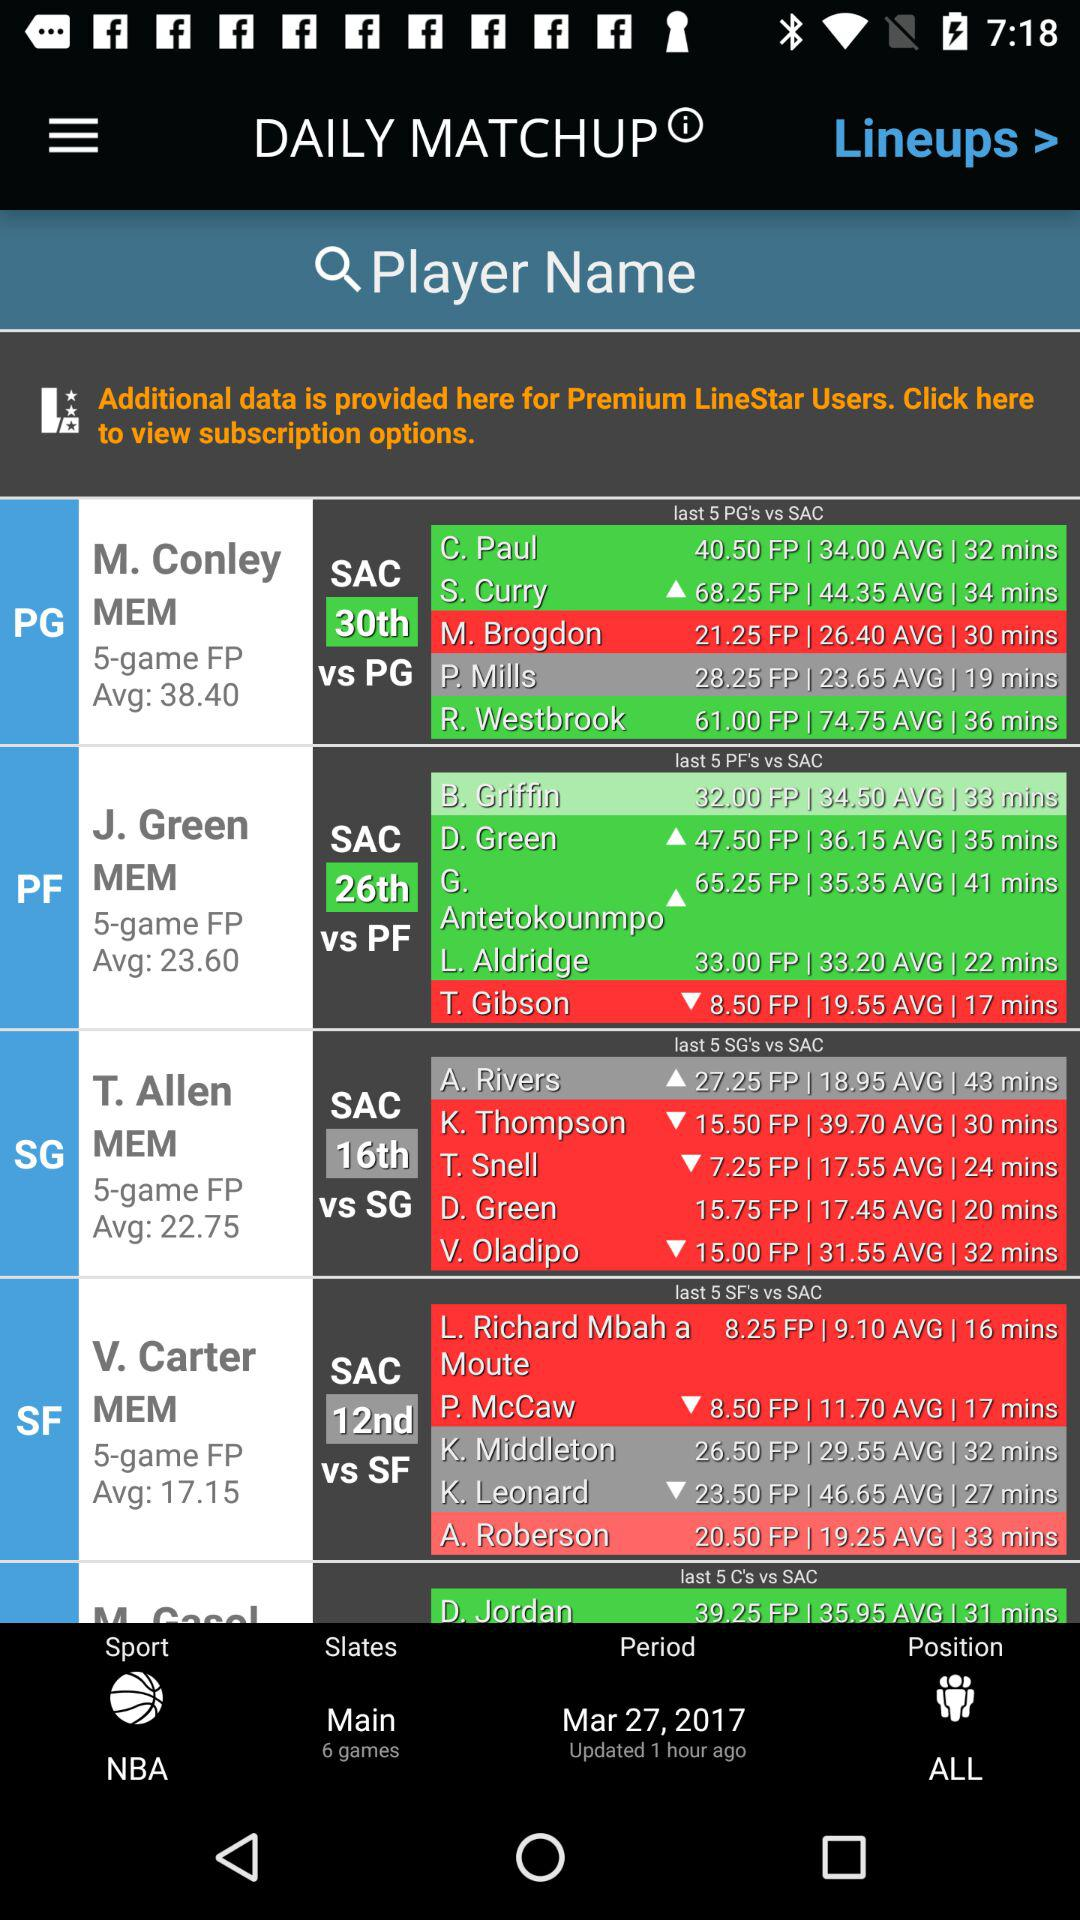What is the average of J. Green MEM? The average of "J. Green MEM" is 23.60. 